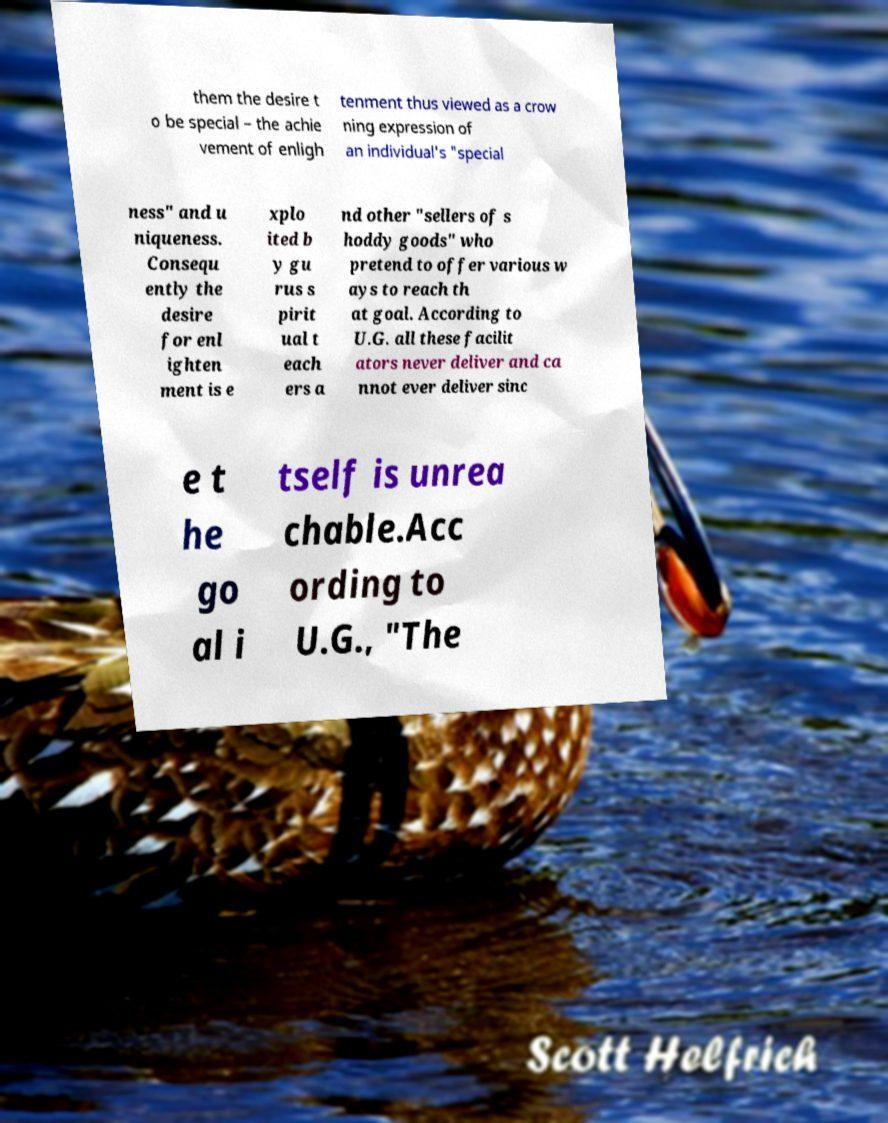What messages or text are displayed in this image? I need them in a readable, typed format. them the desire t o be special – the achie vement of enligh tenment thus viewed as a crow ning expression of an individual's "special ness" and u niqueness. Consequ ently the desire for enl ighten ment is e xplo ited b y gu rus s pirit ual t each ers a nd other "sellers of s hoddy goods" who pretend to offer various w ays to reach th at goal. According to U.G. all these facilit ators never deliver and ca nnot ever deliver sinc e t he go al i tself is unrea chable.Acc ording to U.G., "The 